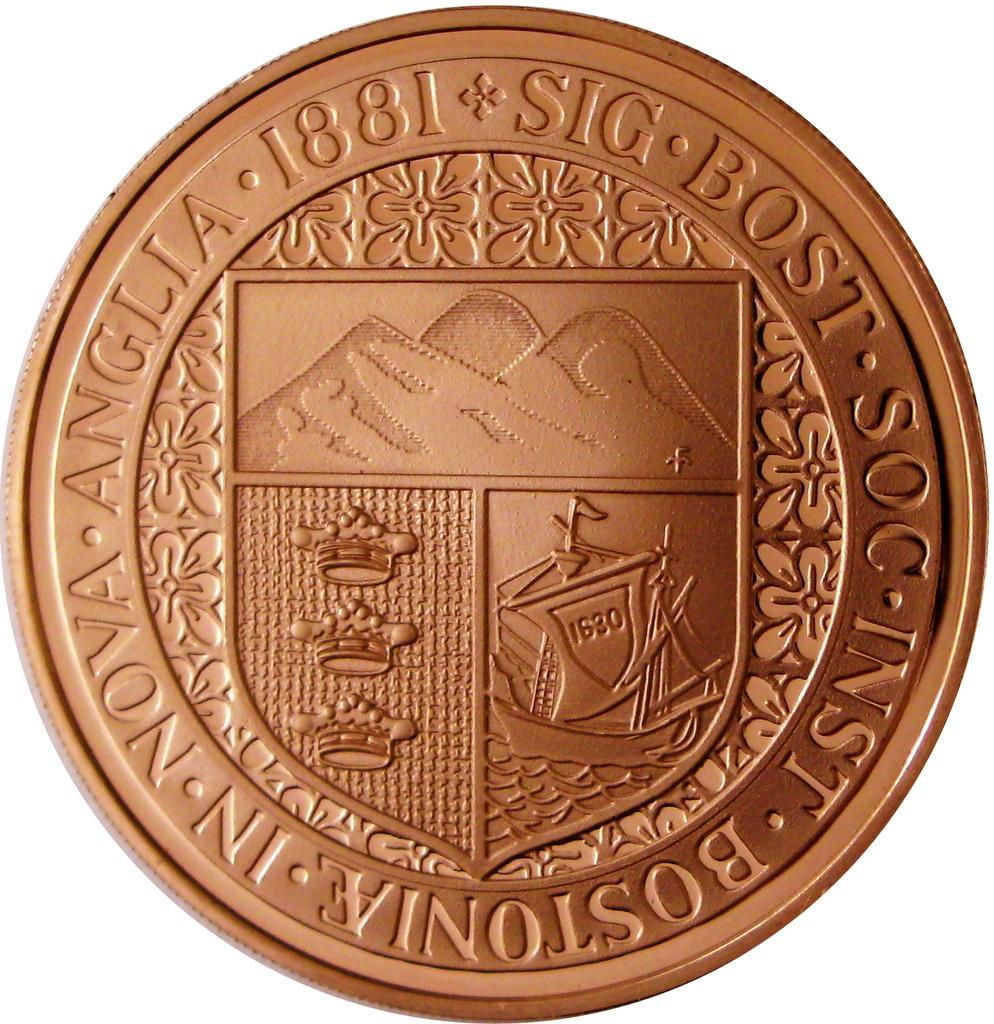<image>
Summarize the visual content of the image. A coin that has a ship on it and it the sail of the ship is 1680 written on it. 